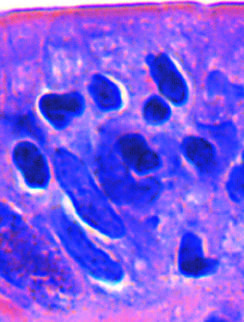nfiltration of the surface epithelium by t lymphocytes , which can be recognized by whose stained nuclei labeled t?
Answer the question using a single word or phrase. Their 